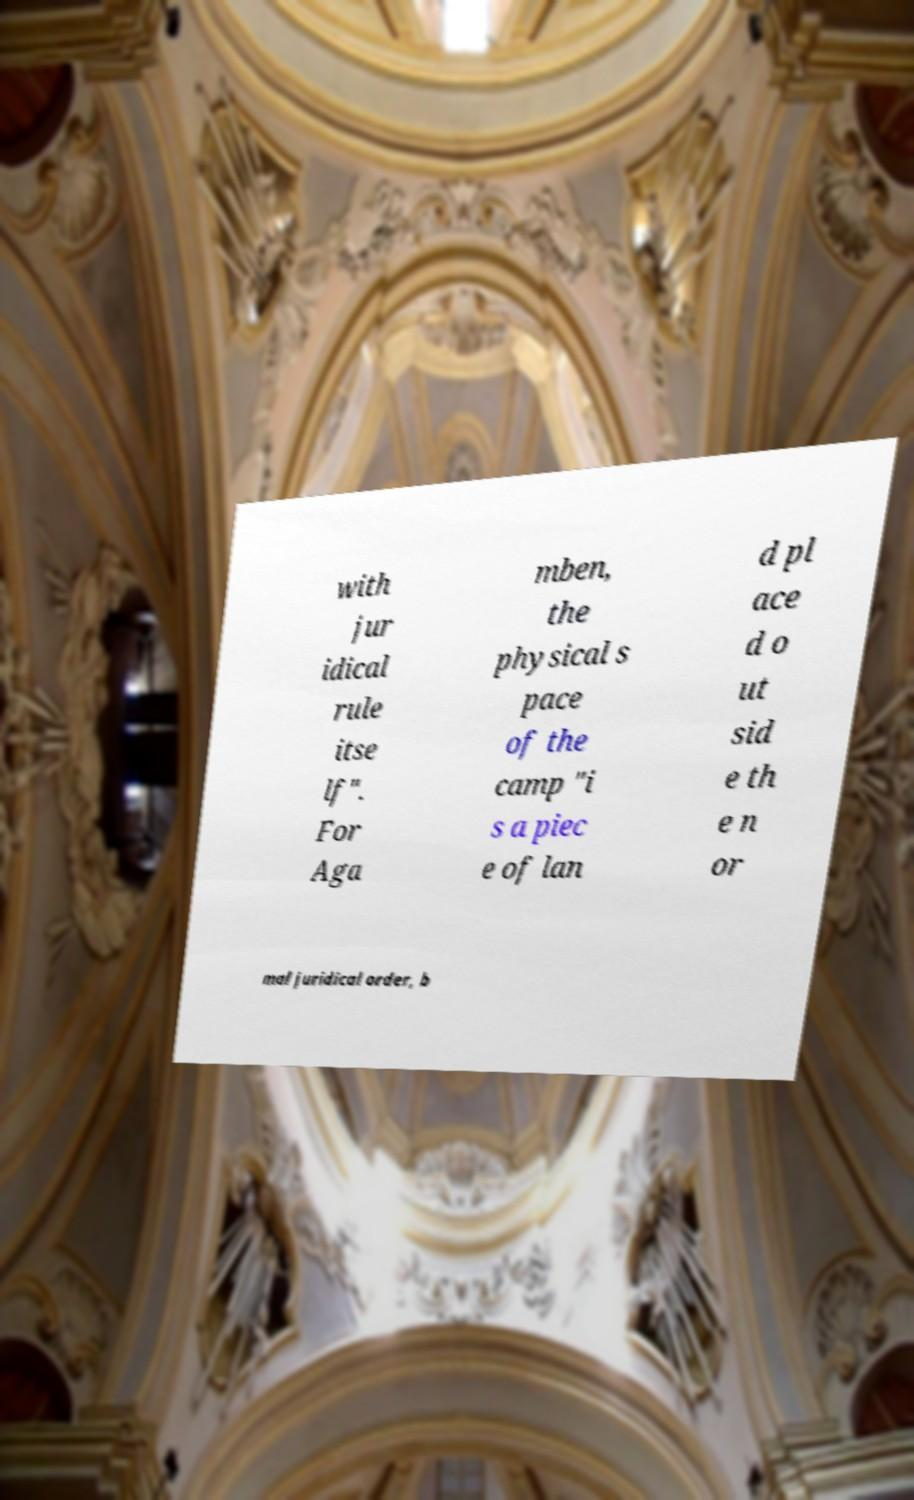Please read and relay the text visible in this image. What does it say? with jur idical rule itse lf". For Aga mben, the physical s pace of the camp "i s a piec e of lan d pl ace d o ut sid e th e n or mal juridical order, b 